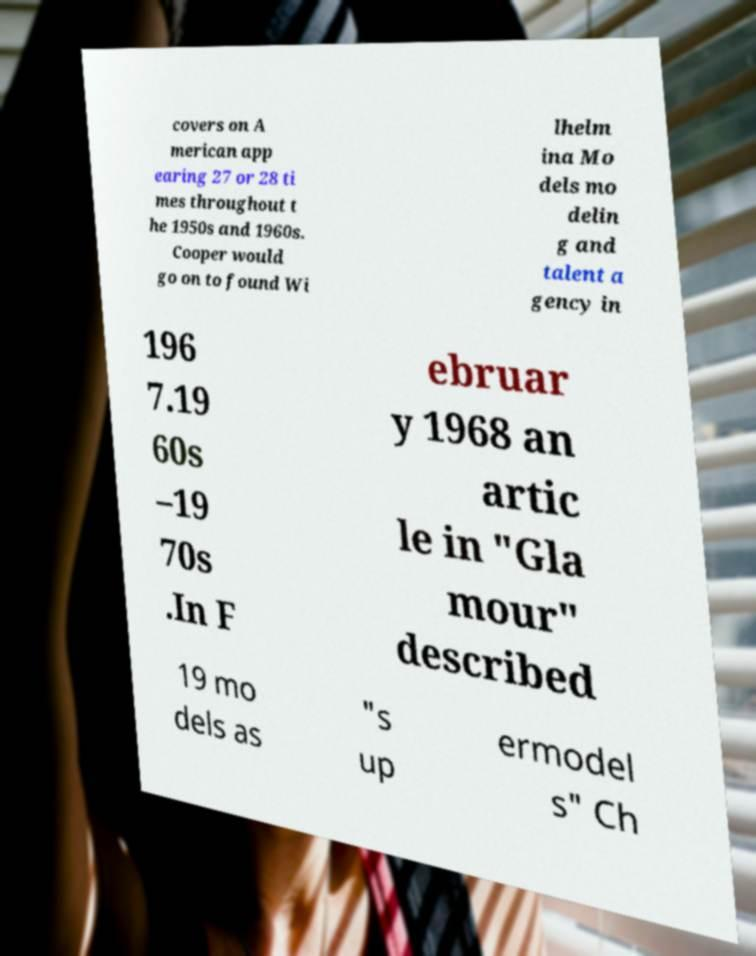There's text embedded in this image that I need extracted. Can you transcribe it verbatim? covers on A merican app earing 27 or 28 ti mes throughout t he 1950s and 1960s. Cooper would go on to found Wi lhelm ina Mo dels mo delin g and talent a gency in 196 7.19 60s –19 70s .In F ebruar y 1968 an artic le in "Gla mour" described 19 mo dels as "s up ermodel s" Ch 